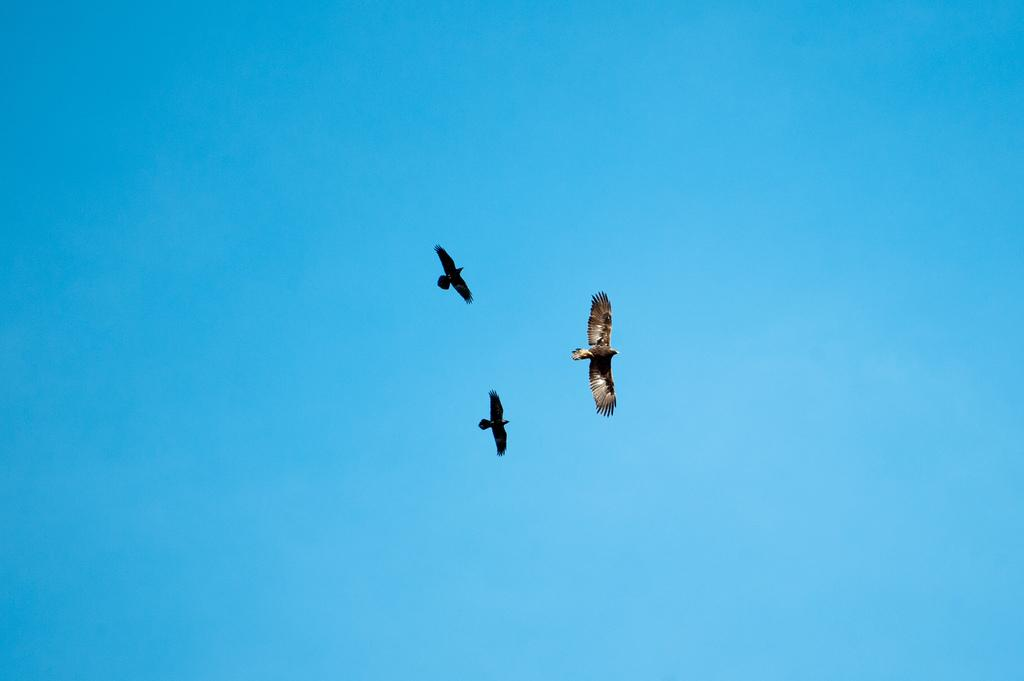How many birds are present in the image? There are three birds in the image. What are the birds doing in the image? The birds are in the air. What can be seen in the background of the image? There is sky visible in the background of the image. What type of marble is visible on the ground in the image? There is no marble visible on the ground in the image; it features three birds in the air with a sky background. 